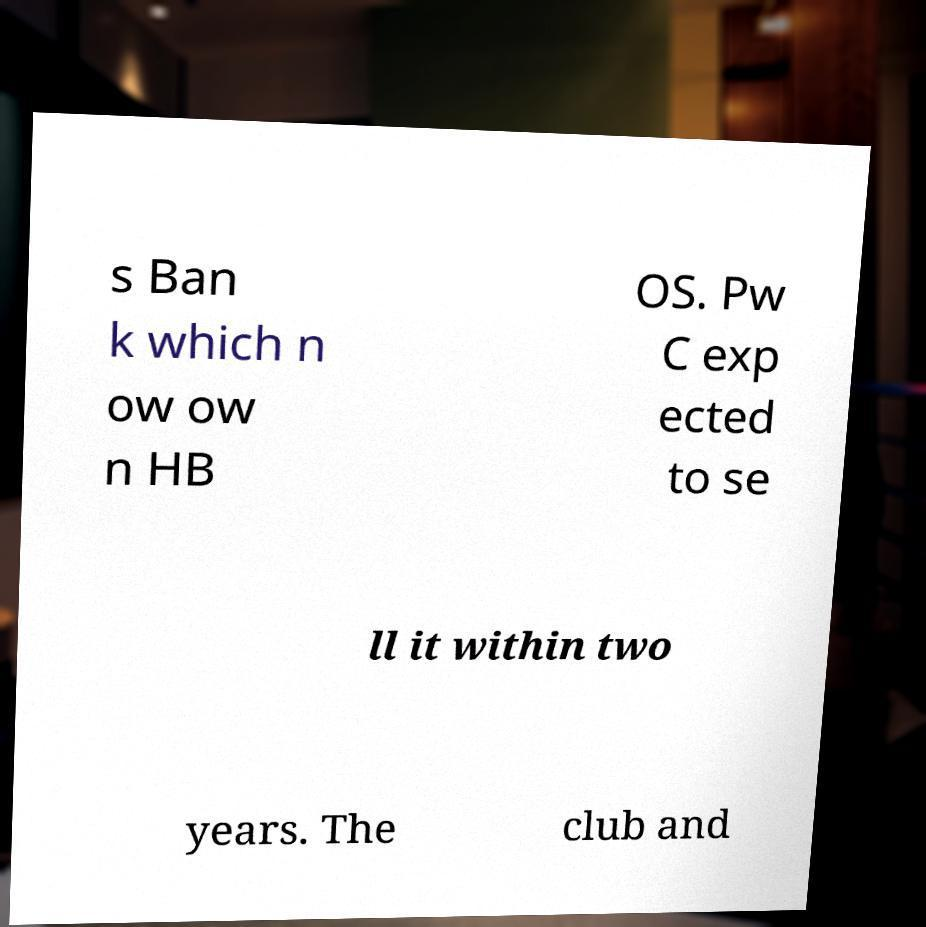Could you extract and type out the text from this image? s Ban k which n ow ow n HB OS. Pw C exp ected to se ll it within two years. The club and 